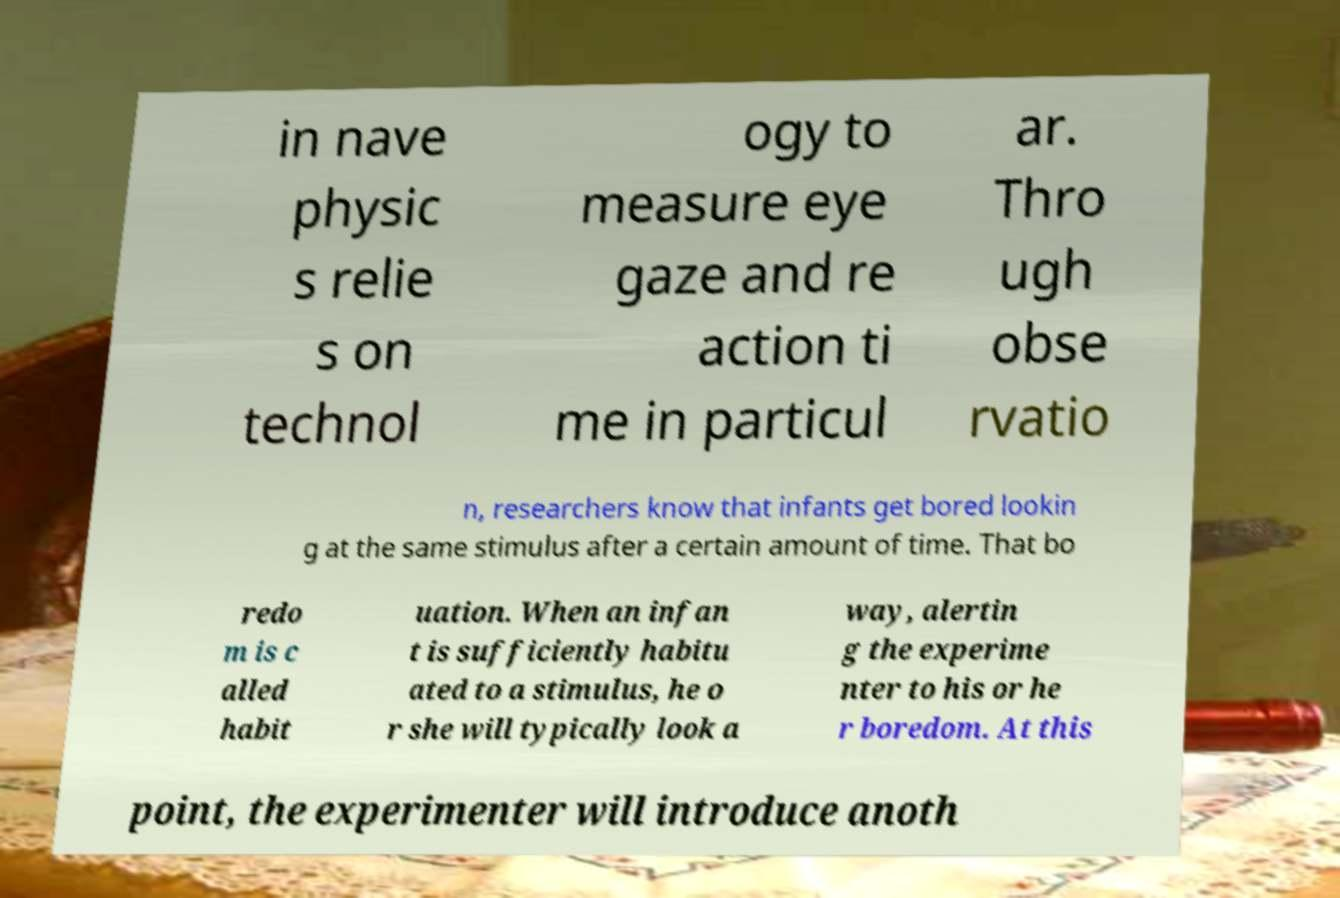There's text embedded in this image that I need extracted. Can you transcribe it verbatim? in nave physic s relie s on technol ogy to measure eye gaze and re action ti me in particul ar. Thro ugh obse rvatio n, researchers know that infants get bored lookin g at the same stimulus after a certain amount of time. That bo redo m is c alled habit uation. When an infan t is sufficiently habitu ated to a stimulus, he o r she will typically look a way, alertin g the experime nter to his or he r boredom. At this point, the experimenter will introduce anoth 